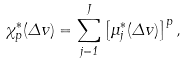<formula> <loc_0><loc_0><loc_500><loc_500>\chi _ { p } ^ { * } ( \Delta { v } ) = \sum _ { j = 1 } ^ { J } \left [ \mu ^ { * } _ { j } ( \Delta { v } ) \right ] ^ { p } ,</formula> 